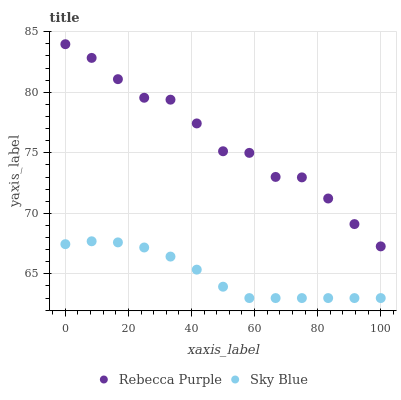Does Sky Blue have the minimum area under the curve?
Answer yes or no. Yes. Does Rebecca Purple have the maximum area under the curve?
Answer yes or no. Yes. Does Rebecca Purple have the minimum area under the curve?
Answer yes or no. No. Is Sky Blue the smoothest?
Answer yes or no. Yes. Is Rebecca Purple the roughest?
Answer yes or no. Yes. Is Rebecca Purple the smoothest?
Answer yes or no. No. Does Sky Blue have the lowest value?
Answer yes or no. Yes. Does Rebecca Purple have the lowest value?
Answer yes or no. No. Does Rebecca Purple have the highest value?
Answer yes or no. Yes. Is Sky Blue less than Rebecca Purple?
Answer yes or no. Yes. Is Rebecca Purple greater than Sky Blue?
Answer yes or no. Yes. Does Sky Blue intersect Rebecca Purple?
Answer yes or no. No. 